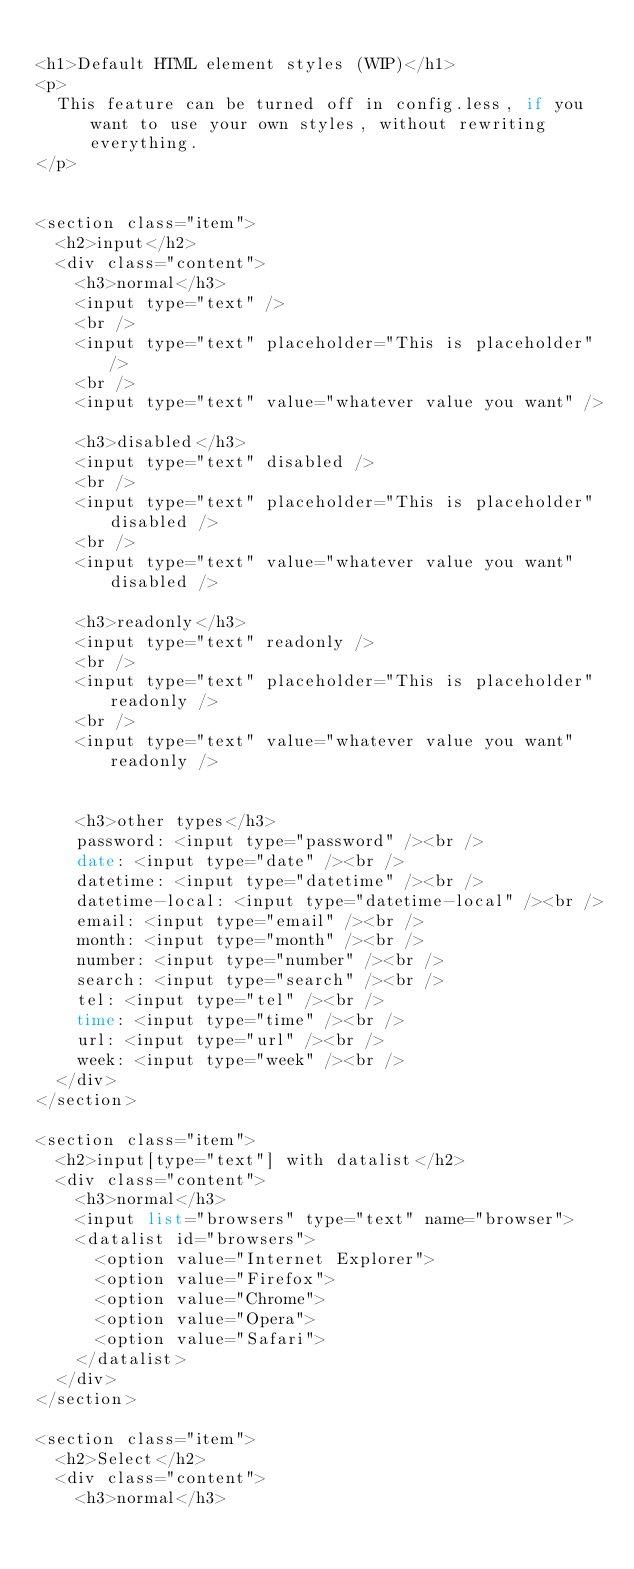Convert code to text. <code><loc_0><loc_0><loc_500><loc_500><_PHP_>
<h1>Default HTML element styles (WIP)</h1>
<p>
	This feature can be turned off in config.less, if you want to use your own styles, without rewriting everything.
</p>


<section class="item">
	<h2>input</h2>
	<div class="content">
		<h3>normal</h3>
		<input type="text" />
		<br />
		<input type="text" placeholder="This is placeholder" />
		<br />
		<input type="text" value="whatever value you want" />
		
		<h3>disabled</h3>
		<input type="text" disabled />
		<br />
		<input type="text" placeholder="This is placeholder" disabled />
		<br />
		<input type="text" value="whatever value you want" disabled />
		
		<h3>readonly</h3>
		<input type="text" readonly />
		<br />
		<input type="text" placeholder="This is placeholder" readonly />
		<br />
		<input type="text" value="whatever value you want" readonly />
		
		
		<h3>other types</h3>
		password: <input type="password" /><br />
		date: <input type="date" /><br />
		datetime: <input type="datetime" /><br />
		datetime-local: <input type="datetime-local" /><br />
		email: <input type="email" /><br />
		month: <input type="month" /><br />
		number: <input type="number" /><br />
		search: <input type="search" /><br />
		tel: <input type="tel" /><br />
		time: <input type="time" /><br />
		url: <input type="url" /><br />
		week: <input type="week" /><br />
	</div>
</section>

<section class="item">
	<h2>input[type="text"] with datalist</h2>
	<div class="content">
		<h3>normal</h3>
		<input list="browsers" type="text" name="browser">
		<datalist id="browsers">
			<option value="Internet Explorer">
			<option value="Firefox">
			<option value="Chrome">
			<option value="Opera">
			<option value="Safari">
		</datalist>
	</div>
</section>

<section class="item">
	<h2>Select</h2>
	<div class="content">
		<h3>normal</h3></code> 